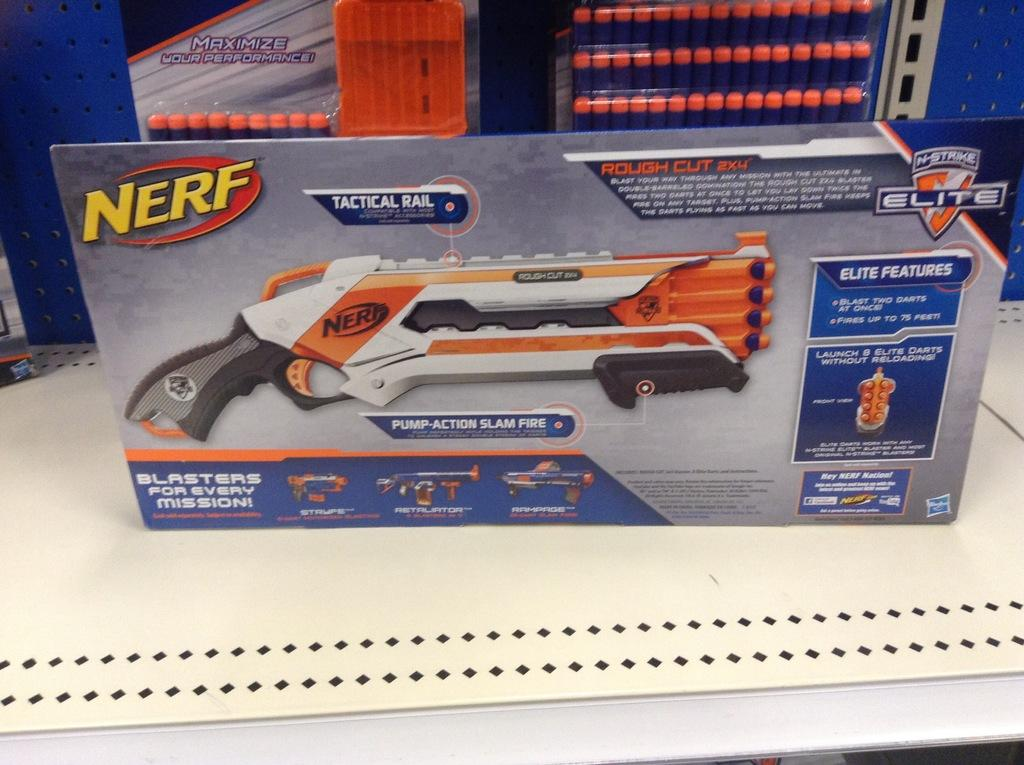What is the primary setting or location depicted in the image? The primary setting depicted in the image is a table. What can be seen on the table in the image? The provided fact only mentions that there are objects on the table, but it does not specify what those objects are. Can you see a ladybug crawling on the brick in the image? There is no mention of a ladybug or a brick in the provided facts, so we cannot determine their presence in the image. 